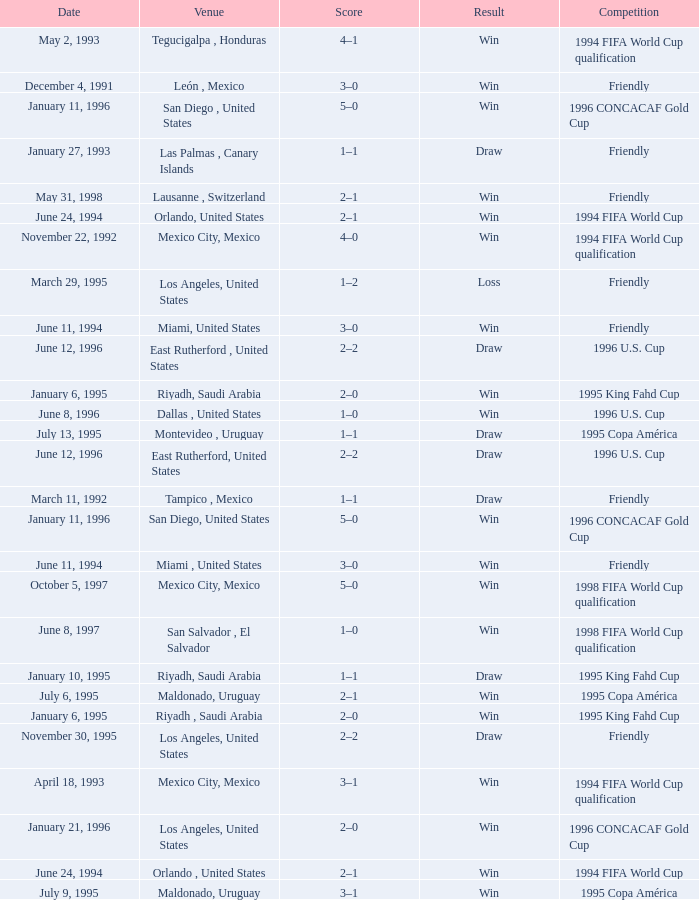What is Venue, when Date is "January 6, 1995"? Riyadh , Saudi Arabia, Riyadh, Saudi Arabia. 